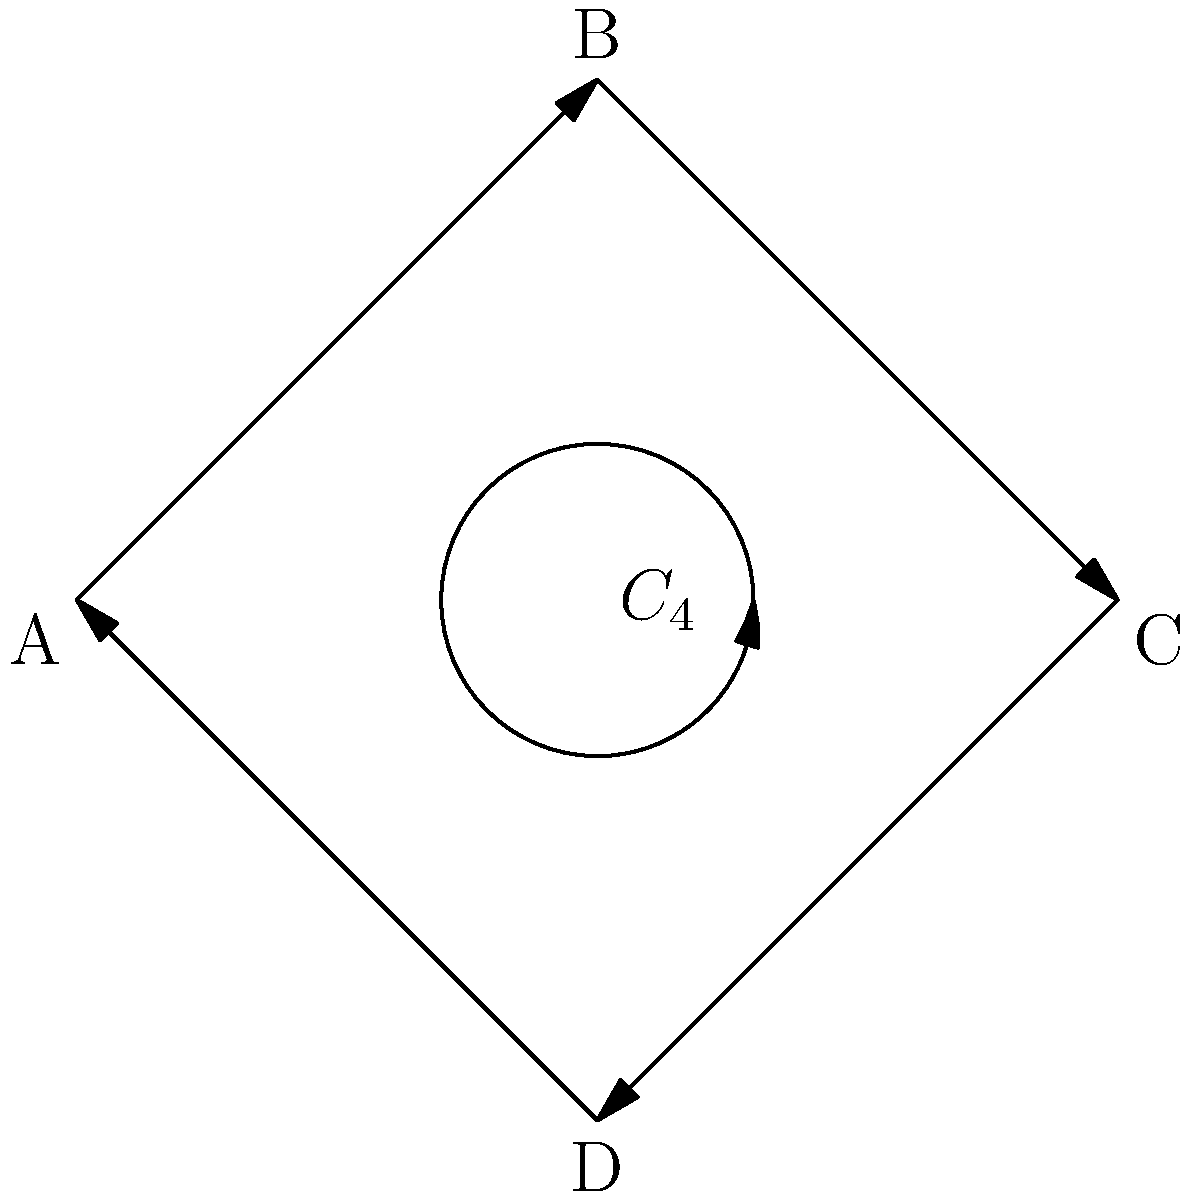A museum's security system consists of four checkpoints (A, B, C, and D) that must be visited in a specific order during each patrol. The diagram shows the possible patrol routes forming a cyclic group $C_4$. If you were to manipulate this system to create a diversion, what is the order of the group representing all possible arrangements of the patrol routes? To determine the order of the group representing all possible arrangements of the patrol routes, we need to follow these steps:

1. Identify the group: The diagram shows a cyclic group $C_4$, which represents the current patrol route system.

2. Understand the elements: In this case, each element of the group represents a different starting point for the patrol route.

3. Count the elements:
   - Starting at A: (A, B, C, D)
   - Starting at B: (B, C, D, A)
   - Starting at C: (C, D, A, B)
   - Starting at D: (D, A, B, C)

4. Recognize the group structure: This is indeed a cyclic group of order 4, as each element generates all others through repeated application.

5. Calculate possible arrangements: To find all possible arrangements, we need to consider permutations of these 4 elements.

6. Apply the permutation formula: The number of permutations of n distinct objects is given by $n!$ (n factorial).

7. Calculate: In this case, $n = 4$, so the number of possible arrangements is $4! = 4 \times 3 \times 2 \times 1 = 24$.

Therefore, the order of the group representing all possible arrangements of the patrol routes is 24.
Answer: 24 